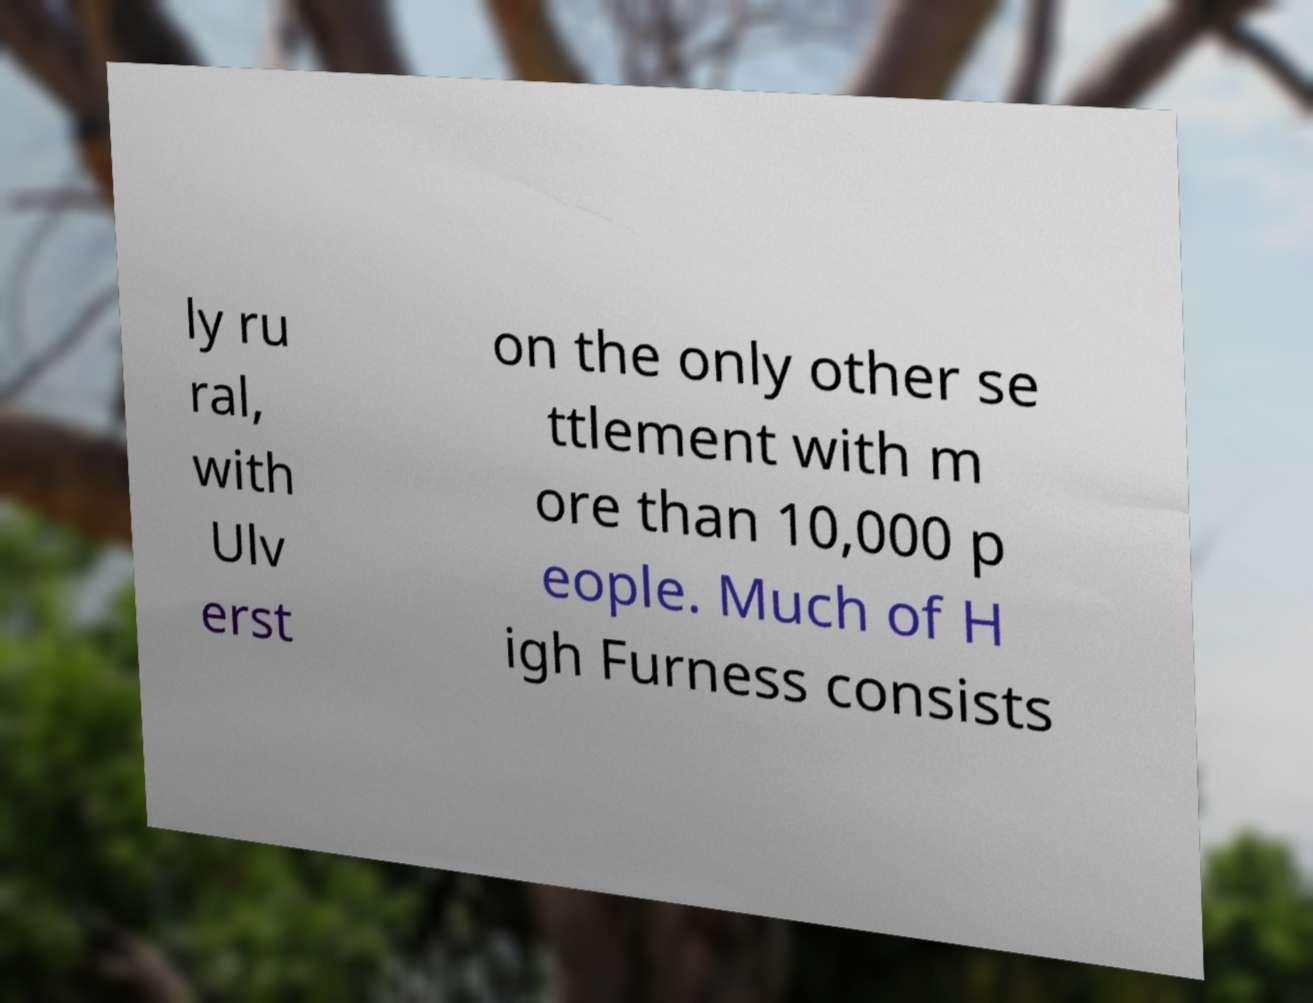Can you accurately transcribe the text from the provided image for me? ly ru ral, with Ulv erst on the only other se ttlement with m ore than 10,000 p eople. Much of H igh Furness consists 